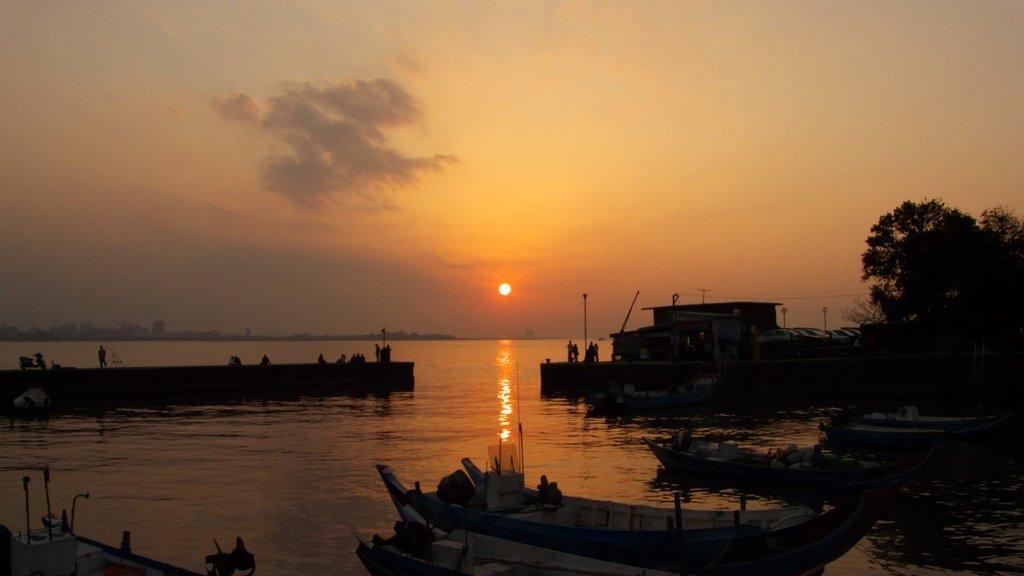Describe this image in one or two sentences. In this image we can see some boats in a water body. We can also see some people standing on the deck, some poles, a house, some wires and trees. On the backside we can see some buildings, the sun and the sky which looks cloudy. 